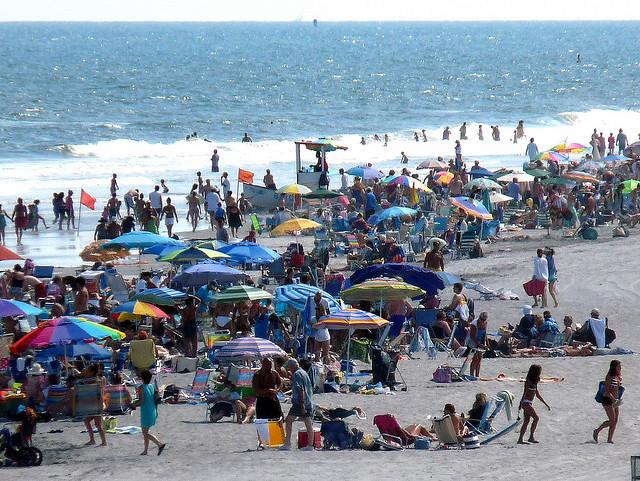Is it raining?
Give a very brief answer. No. Is there a lifeguard stand on the beach?
Short answer required. Yes. Is this beach crowded?
Be succinct. Yes. 